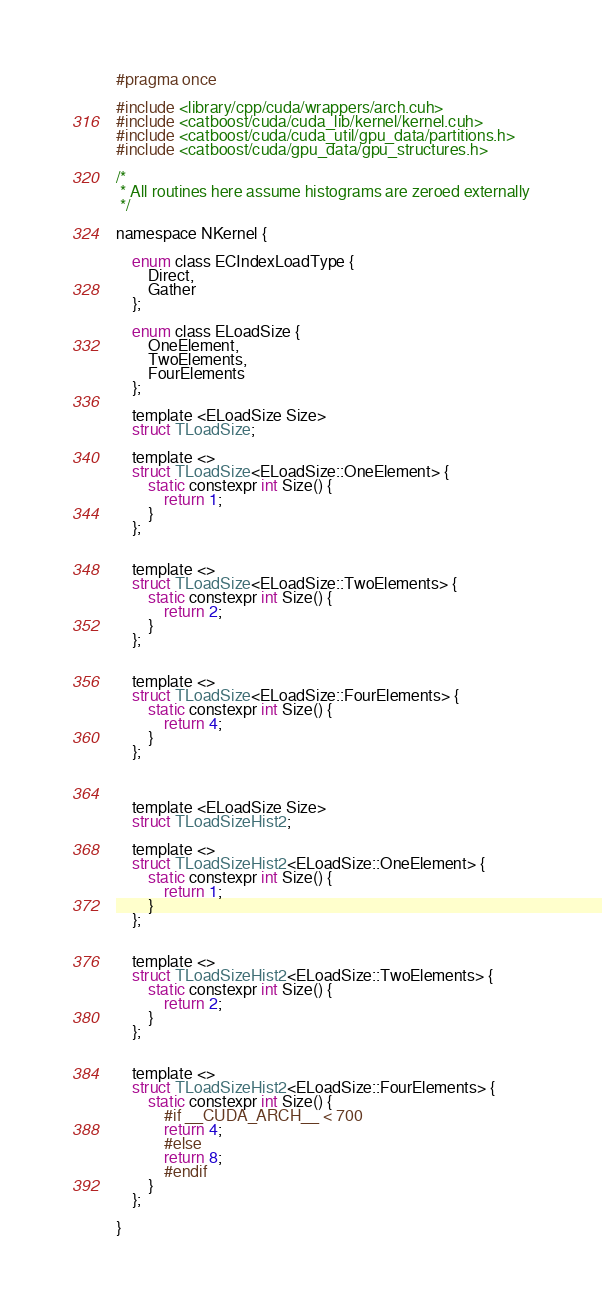Convert code to text. <code><loc_0><loc_0><loc_500><loc_500><_Cuda_>#pragma once

#include <library/cpp/cuda/wrappers/arch.cuh>
#include <catboost/cuda/cuda_lib/kernel/kernel.cuh>
#include <catboost/cuda/cuda_util/gpu_data/partitions.h>
#include <catboost/cuda/gpu_data/gpu_structures.h>

/*
 * All routines here assume histograms are zeroed externally
 */

namespace NKernel {

    enum class ECIndexLoadType {
        Direct,
        Gather
    };

    enum class ELoadSize {
        OneElement,
        TwoElements,
        FourElements
    };

    template <ELoadSize Size>
    struct TLoadSize;

    template <>
    struct TLoadSize<ELoadSize::OneElement> {
        static constexpr int Size() {
            return 1;
        }
    };


    template <>
    struct TLoadSize<ELoadSize::TwoElements> {
        static constexpr int Size() {
            return 2;
        }
    };


    template <>
    struct TLoadSize<ELoadSize::FourElements> {
        static constexpr int Size() {
            return 4;
        }
    };



    template <ELoadSize Size>
    struct TLoadSizeHist2;

    template <>
    struct TLoadSizeHist2<ELoadSize::OneElement> {
        static constexpr int Size() {
            return 1;
        }
    };


    template <>
    struct TLoadSizeHist2<ELoadSize::TwoElements> {
        static constexpr int Size() {
            return 2;
        }
    };


    template <>
    struct TLoadSizeHist2<ELoadSize::FourElements> {
        static constexpr int Size() {
            #if __CUDA_ARCH__ < 700
            return 4;
            #else
            return 8;
            #endif
        }
    };

}
</code> 